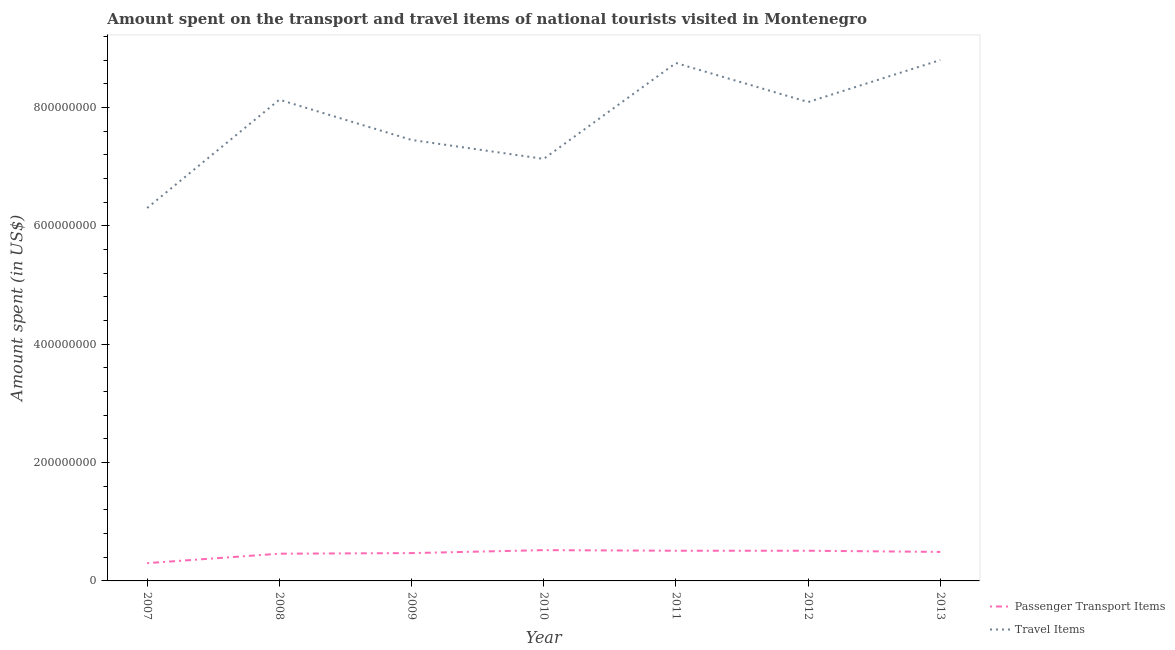How many different coloured lines are there?
Give a very brief answer. 2. What is the amount spent on passenger transport items in 2007?
Your response must be concise. 3.00e+07. Across all years, what is the maximum amount spent in travel items?
Make the answer very short. 8.80e+08. Across all years, what is the minimum amount spent on passenger transport items?
Give a very brief answer. 3.00e+07. In which year was the amount spent on passenger transport items maximum?
Offer a terse response. 2010. What is the total amount spent on passenger transport items in the graph?
Give a very brief answer. 3.26e+08. What is the difference between the amount spent in travel items in 2007 and the amount spent on passenger transport items in 2008?
Ensure brevity in your answer.  5.84e+08. What is the average amount spent on passenger transport items per year?
Your answer should be compact. 4.66e+07. In the year 2010, what is the difference between the amount spent on passenger transport items and amount spent in travel items?
Offer a very short reply. -6.61e+08. Is the amount spent in travel items in 2011 less than that in 2012?
Provide a succinct answer. No. What is the difference between the highest and the second highest amount spent on passenger transport items?
Offer a very short reply. 1.00e+06. What is the difference between the highest and the lowest amount spent in travel items?
Your answer should be very brief. 2.50e+08. Is the sum of the amount spent on passenger transport items in 2009 and 2011 greater than the maximum amount spent in travel items across all years?
Make the answer very short. No. Does the amount spent in travel items monotonically increase over the years?
Your answer should be very brief. No. Is the amount spent on passenger transport items strictly greater than the amount spent in travel items over the years?
Give a very brief answer. No. How many lines are there?
Provide a succinct answer. 2. What is the difference between two consecutive major ticks on the Y-axis?
Offer a very short reply. 2.00e+08. Does the graph contain any zero values?
Give a very brief answer. No. Does the graph contain grids?
Provide a short and direct response. No. Where does the legend appear in the graph?
Offer a terse response. Bottom right. How are the legend labels stacked?
Offer a terse response. Vertical. What is the title of the graph?
Provide a short and direct response. Amount spent on the transport and travel items of national tourists visited in Montenegro. Does "Overweight" appear as one of the legend labels in the graph?
Ensure brevity in your answer.  No. What is the label or title of the Y-axis?
Give a very brief answer. Amount spent (in US$). What is the Amount spent (in US$) of Passenger Transport Items in 2007?
Your response must be concise. 3.00e+07. What is the Amount spent (in US$) of Travel Items in 2007?
Provide a short and direct response. 6.30e+08. What is the Amount spent (in US$) in Passenger Transport Items in 2008?
Offer a very short reply. 4.60e+07. What is the Amount spent (in US$) of Travel Items in 2008?
Make the answer very short. 8.13e+08. What is the Amount spent (in US$) in Passenger Transport Items in 2009?
Give a very brief answer. 4.70e+07. What is the Amount spent (in US$) of Travel Items in 2009?
Ensure brevity in your answer.  7.45e+08. What is the Amount spent (in US$) of Passenger Transport Items in 2010?
Ensure brevity in your answer.  5.20e+07. What is the Amount spent (in US$) in Travel Items in 2010?
Provide a short and direct response. 7.13e+08. What is the Amount spent (in US$) of Passenger Transport Items in 2011?
Keep it short and to the point. 5.10e+07. What is the Amount spent (in US$) in Travel Items in 2011?
Give a very brief answer. 8.75e+08. What is the Amount spent (in US$) of Passenger Transport Items in 2012?
Make the answer very short. 5.10e+07. What is the Amount spent (in US$) of Travel Items in 2012?
Offer a terse response. 8.09e+08. What is the Amount spent (in US$) in Passenger Transport Items in 2013?
Your response must be concise. 4.90e+07. What is the Amount spent (in US$) of Travel Items in 2013?
Provide a succinct answer. 8.80e+08. Across all years, what is the maximum Amount spent (in US$) in Passenger Transport Items?
Offer a very short reply. 5.20e+07. Across all years, what is the maximum Amount spent (in US$) in Travel Items?
Keep it short and to the point. 8.80e+08. Across all years, what is the minimum Amount spent (in US$) of Passenger Transport Items?
Offer a terse response. 3.00e+07. Across all years, what is the minimum Amount spent (in US$) of Travel Items?
Give a very brief answer. 6.30e+08. What is the total Amount spent (in US$) in Passenger Transport Items in the graph?
Offer a very short reply. 3.26e+08. What is the total Amount spent (in US$) of Travel Items in the graph?
Give a very brief answer. 5.46e+09. What is the difference between the Amount spent (in US$) in Passenger Transport Items in 2007 and that in 2008?
Keep it short and to the point. -1.60e+07. What is the difference between the Amount spent (in US$) in Travel Items in 2007 and that in 2008?
Offer a terse response. -1.83e+08. What is the difference between the Amount spent (in US$) in Passenger Transport Items in 2007 and that in 2009?
Give a very brief answer. -1.70e+07. What is the difference between the Amount spent (in US$) of Travel Items in 2007 and that in 2009?
Your answer should be compact. -1.15e+08. What is the difference between the Amount spent (in US$) in Passenger Transport Items in 2007 and that in 2010?
Keep it short and to the point. -2.20e+07. What is the difference between the Amount spent (in US$) in Travel Items in 2007 and that in 2010?
Your response must be concise. -8.30e+07. What is the difference between the Amount spent (in US$) in Passenger Transport Items in 2007 and that in 2011?
Offer a very short reply. -2.10e+07. What is the difference between the Amount spent (in US$) in Travel Items in 2007 and that in 2011?
Give a very brief answer. -2.45e+08. What is the difference between the Amount spent (in US$) of Passenger Transport Items in 2007 and that in 2012?
Your response must be concise. -2.10e+07. What is the difference between the Amount spent (in US$) of Travel Items in 2007 and that in 2012?
Your answer should be very brief. -1.79e+08. What is the difference between the Amount spent (in US$) in Passenger Transport Items in 2007 and that in 2013?
Provide a succinct answer. -1.90e+07. What is the difference between the Amount spent (in US$) in Travel Items in 2007 and that in 2013?
Ensure brevity in your answer.  -2.50e+08. What is the difference between the Amount spent (in US$) of Passenger Transport Items in 2008 and that in 2009?
Your response must be concise. -1.00e+06. What is the difference between the Amount spent (in US$) of Travel Items in 2008 and that in 2009?
Provide a short and direct response. 6.80e+07. What is the difference between the Amount spent (in US$) of Passenger Transport Items in 2008 and that in 2010?
Make the answer very short. -6.00e+06. What is the difference between the Amount spent (in US$) of Passenger Transport Items in 2008 and that in 2011?
Keep it short and to the point. -5.00e+06. What is the difference between the Amount spent (in US$) in Travel Items in 2008 and that in 2011?
Keep it short and to the point. -6.20e+07. What is the difference between the Amount spent (in US$) of Passenger Transport Items in 2008 and that in 2012?
Provide a short and direct response. -5.00e+06. What is the difference between the Amount spent (in US$) of Passenger Transport Items in 2008 and that in 2013?
Offer a very short reply. -3.00e+06. What is the difference between the Amount spent (in US$) in Travel Items in 2008 and that in 2013?
Keep it short and to the point. -6.70e+07. What is the difference between the Amount spent (in US$) of Passenger Transport Items in 2009 and that in 2010?
Your response must be concise. -5.00e+06. What is the difference between the Amount spent (in US$) of Travel Items in 2009 and that in 2010?
Ensure brevity in your answer.  3.20e+07. What is the difference between the Amount spent (in US$) of Travel Items in 2009 and that in 2011?
Give a very brief answer. -1.30e+08. What is the difference between the Amount spent (in US$) in Travel Items in 2009 and that in 2012?
Your answer should be compact. -6.40e+07. What is the difference between the Amount spent (in US$) in Passenger Transport Items in 2009 and that in 2013?
Offer a terse response. -2.00e+06. What is the difference between the Amount spent (in US$) in Travel Items in 2009 and that in 2013?
Provide a succinct answer. -1.35e+08. What is the difference between the Amount spent (in US$) in Passenger Transport Items in 2010 and that in 2011?
Your answer should be compact. 1.00e+06. What is the difference between the Amount spent (in US$) in Travel Items in 2010 and that in 2011?
Provide a short and direct response. -1.62e+08. What is the difference between the Amount spent (in US$) of Travel Items in 2010 and that in 2012?
Offer a very short reply. -9.60e+07. What is the difference between the Amount spent (in US$) of Travel Items in 2010 and that in 2013?
Make the answer very short. -1.67e+08. What is the difference between the Amount spent (in US$) in Travel Items in 2011 and that in 2012?
Your answer should be compact. 6.60e+07. What is the difference between the Amount spent (in US$) of Travel Items in 2011 and that in 2013?
Your answer should be compact. -5.00e+06. What is the difference between the Amount spent (in US$) of Travel Items in 2012 and that in 2013?
Your answer should be very brief. -7.10e+07. What is the difference between the Amount spent (in US$) of Passenger Transport Items in 2007 and the Amount spent (in US$) of Travel Items in 2008?
Offer a terse response. -7.83e+08. What is the difference between the Amount spent (in US$) of Passenger Transport Items in 2007 and the Amount spent (in US$) of Travel Items in 2009?
Your answer should be very brief. -7.15e+08. What is the difference between the Amount spent (in US$) in Passenger Transport Items in 2007 and the Amount spent (in US$) in Travel Items in 2010?
Ensure brevity in your answer.  -6.83e+08. What is the difference between the Amount spent (in US$) of Passenger Transport Items in 2007 and the Amount spent (in US$) of Travel Items in 2011?
Provide a short and direct response. -8.45e+08. What is the difference between the Amount spent (in US$) in Passenger Transport Items in 2007 and the Amount spent (in US$) in Travel Items in 2012?
Provide a short and direct response. -7.79e+08. What is the difference between the Amount spent (in US$) of Passenger Transport Items in 2007 and the Amount spent (in US$) of Travel Items in 2013?
Your answer should be very brief. -8.50e+08. What is the difference between the Amount spent (in US$) in Passenger Transport Items in 2008 and the Amount spent (in US$) in Travel Items in 2009?
Provide a succinct answer. -6.99e+08. What is the difference between the Amount spent (in US$) of Passenger Transport Items in 2008 and the Amount spent (in US$) of Travel Items in 2010?
Your answer should be very brief. -6.67e+08. What is the difference between the Amount spent (in US$) in Passenger Transport Items in 2008 and the Amount spent (in US$) in Travel Items in 2011?
Give a very brief answer. -8.29e+08. What is the difference between the Amount spent (in US$) in Passenger Transport Items in 2008 and the Amount spent (in US$) in Travel Items in 2012?
Provide a succinct answer. -7.63e+08. What is the difference between the Amount spent (in US$) of Passenger Transport Items in 2008 and the Amount spent (in US$) of Travel Items in 2013?
Your answer should be very brief. -8.34e+08. What is the difference between the Amount spent (in US$) of Passenger Transport Items in 2009 and the Amount spent (in US$) of Travel Items in 2010?
Offer a very short reply. -6.66e+08. What is the difference between the Amount spent (in US$) of Passenger Transport Items in 2009 and the Amount spent (in US$) of Travel Items in 2011?
Your response must be concise. -8.28e+08. What is the difference between the Amount spent (in US$) in Passenger Transport Items in 2009 and the Amount spent (in US$) in Travel Items in 2012?
Offer a very short reply. -7.62e+08. What is the difference between the Amount spent (in US$) in Passenger Transport Items in 2009 and the Amount spent (in US$) in Travel Items in 2013?
Offer a terse response. -8.33e+08. What is the difference between the Amount spent (in US$) in Passenger Transport Items in 2010 and the Amount spent (in US$) in Travel Items in 2011?
Your answer should be compact. -8.23e+08. What is the difference between the Amount spent (in US$) in Passenger Transport Items in 2010 and the Amount spent (in US$) in Travel Items in 2012?
Offer a very short reply. -7.57e+08. What is the difference between the Amount spent (in US$) in Passenger Transport Items in 2010 and the Amount spent (in US$) in Travel Items in 2013?
Ensure brevity in your answer.  -8.28e+08. What is the difference between the Amount spent (in US$) in Passenger Transport Items in 2011 and the Amount spent (in US$) in Travel Items in 2012?
Offer a very short reply. -7.58e+08. What is the difference between the Amount spent (in US$) of Passenger Transport Items in 2011 and the Amount spent (in US$) of Travel Items in 2013?
Make the answer very short. -8.29e+08. What is the difference between the Amount spent (in US$) of Passenger Transport Items in 2012 and the Amount spent (in US$) of Travel Items in 2013?
Keep it short and to the point. -8.29e+08. What is the average Amount spent (in US$) of Passenger Transport Items per year?
Keep it short and to the point. 4.66e+07. What is the average Amount spent (in US$) in Travel Items per year?
Your response must be concise. 7.81e+08. In the year 2007, what is the difference between the Amount spent (in US$) of Passenger Transport Items and Amount spent (in US$) of Travel Items?
Keep it short and to the point. -6.00e+08. In the year 2008, what is the difference between the Amount spent (in US$) of Passenger Transport Items and Amount spent (in US$) of Travel Items?
Keep it short and to the point. -7.67e+08. In the year 2009, what is the difference between the Amount spent (in US$) of Passenger Transport Items and Amount spent (in US$) of Travel Items?
Ensure brevity in your answer.  -6.98e+08. In the year 2010, what is the difference between the Amount spent (in US$) in Passenger Transport Items and Amount spent (in US$) in Travel Items?
Your response must be concise. -6.61e+08. In the year 2011, what is the difference between the Amount spent (in US$) of Passenger Transport Items and Amount spent (in US$) of Travel Items?
Offer a terse response. -8.24e+08. In the year 2012, what is the difference between the Amount spent (in US$) of Passenger Transport Items and Amount spent (in US$) of Travel Items?
Your answer should be compact. -7.58e+08. In the year 2013, what is the difference between the Amount spent (in US$) of Passenger Transport Items and Amount spent (in US$) of Travel Items?
Your answer should be very brief. -8.31e+08. What is the ratio of the Amount spent (in US$) of Passenger Transport Items in 2007 to that in 2008?
Make the answer very short. 0.65. What is the ratio of the Amount spent (in US$) in Travel Items in 2007 to that in 2008?
Keep it short and to the point. 0.77. What is the ratio of the Amount spent (in US$) of Passenger Transport Items in 2007 to that in 2009?
Your answer should be compact. 0.64. What is the ratio of the Amount spent (in US$) of Travel Items in 2007 to that in 2009?
Provide a short and direct response. 0.85. What is the ratio of the Amount spent (in US$) in Passenger Transport Items in 2007 to that in 2010?
Make the answer very short. 0.58. What is the ratio of the Amount spent (in US$) in Travel Items in 2007 to that in 2010?
Provide a succinct answer. 0.88. What is the ratio of the Amount spent (in US$) of Passenger Transport Items in 2007 to that in 2011?
Ensure brevity in your answer.  0.59. What is the ratio of the Amount spent (in US$) in Travel Items in 2007 to that in 2011?
Ensure brevity in your answer.  0.72. What is the ratio of the Amount spent (in US$) of Passenger Transport Items in 2007 to that in 2012?
Keep it short and to the point. 0.59. What is the ratio of the Amount spent (in US$) in Travel Items in 2007 to that in 2012?
Give a very brief answer. 0.78. What is the ratio of the Amount spent (in US$) in Passenger Transport Items in 2007 to that in 2013?
Provide a succinct answer. 0.61. What is the ratio of the Amount spent (in US$) in Travel Items in 2007 to that in 2013?
Provide a succinct answer. 0.72. What is the ratio of the Amount spent (in US$) of Passenger Transport Items in 2008 to that in 2009?
Offer a terse response. 0.98. What is the ratio of the Amount spent (in US$) in Travel Items in 2008 to that in 2009?
Make the answer very short. 1.09. What is the ratio of the Amount spent (in US$) in Passenger Transport Items in 2008 to that in 2010?
Offer a very short reply. 0.88. What is the ratio of the Amount spent (in US$) of Travel Items in 2008 to that in 2010?
Ensure brevity in your answer.  1.14. What is the ratio of the Amount spent (in US$) of Passenger Transport Items in 2008 to that in 2011?
Your answer should be compact. 0.9. What is the ratio of the Amount spent (in US$) of Travel Items in 2008 to that in 2011?
Your response must be concise. 0.93. What is the ratio of the Amount spent (in US$) of Passenger Transport Items in 2008 to that in 2012?
Your answer should be compact. 0.9. What is the ratio of the Amount spent (in US$) in Travel Items in 2008 to that in 2012?
Give a very brief answer. 1. What is the ratio of the Amount spent (in US$) in Passenger Transport Items in 2008 to that in 2013?
Provide a succinct answer. 0.94. What is the ratio of the Amount spent (in US$) of Travel Items in 2008 to that in 2013?
Provide a succinct answer. 0.92. What is the ratio of the Amount spent (in US$) of Passenger Transport Items in 2009 to that in 2010?
Offer a terse response. 0.9. What is the ratio of the Amount spent (in US$) of Travel Items in 2009 to that in 2010?
Keep it short and to the point. 1.04. What is the ratio of the Amount spent (in US$) in Passenger Transport Items in 2009 to that in 2011?
Make the answer very short. 0.92. What is the ratio of the Amount spent (in US$) in Travel Items in 2009 to that in 2011?
Keep it short and to the point. 0.85. What is the ratio of the Amount spent (in US$) in Passenger Transport Items in 2009 to that in 2012?
Your response must be concise. 0.92. What is the ratio of the Amount spent (in US$) of Travel Items in 2009 to that in 2012?
Ensure brevity in your answer.  0.92. What is the ratio of the Amount spent (in US$) in Passenger Transport Items in 2009 to that in 2013?
Your response must be concise. 0.96. What is the ratio of the Amount spent (in US$) in Travel Items in 2009 to that in 2013?
Your answer should be very brief. 0.85. What is the ratio of the Amount spent (in US$) in Passenger Transport Items in 2010 to that in 2011?
Offer a terse response. 1.02. What is the ratio of the Amount spent (in US$) in Travel Items in 2010 to that in 2011?
Offer a terse response. 0.81. What is the ratio of the Amount spent (in US$) in Passenger Transport Items in 2010 to that in 2012?
Keep it short and to the point. 1.02. What is the ratio of the Amount spent (in US$) in Travel Items in 2010 to that in 2012?
Your answer should be compact. 0.88. What is the ratio of the Amount spent (in US$) of Passenger Transport Items in 2010 to that in 2013?
Provide a succinct answer. 1.06. What is the ratio of the Amount spent (in US$) of Travel Items in 2010 to that in 2013?
Offer a terse response. 0.81. What is the ratio of the Amount spent (in US$) in Passenger Transport Items in 2011 to that in 2012?
Your response must be concise. 1. What is the ratio of the Amount spent (in US$) in Travel Items in 2011 to that in 2012?
Offer a very short reply. 1.08. What is the ratio of the Amount spent (in US$) of Passenger Transport Items in 2011 to that in 2013?
Ensure brevity in your answer.  1.04. What is the ratio of the Amount spent (in US$) of Travel Items in 2011 to that in 2013?
Make the answer very short. 0.99. What is the ratio of the Amount spent (in US$) of Passenger Transport Items in 2012 to that in 2013?
Your answer should be very brief. 1.04. What is the ratio of the Amount spent (in US$) in Travel Items in 2012 to that in 2013?
Provide a succinct answer. 0.92. What is the difference between the highest and the second highest Amount spent (in US$) of Passenger Transport Items?
Offer a terse response. 1.00e+06. What is the difference between the highest and the lowest Amount spent (in US$) of Passenger Transport Items?
Offer a very short reply. 2.20e+07. What is the difference between the highest and the lowest Amount spent (in US$) in Travel Items?
Provide a short and direct response. 2.50e+08. 